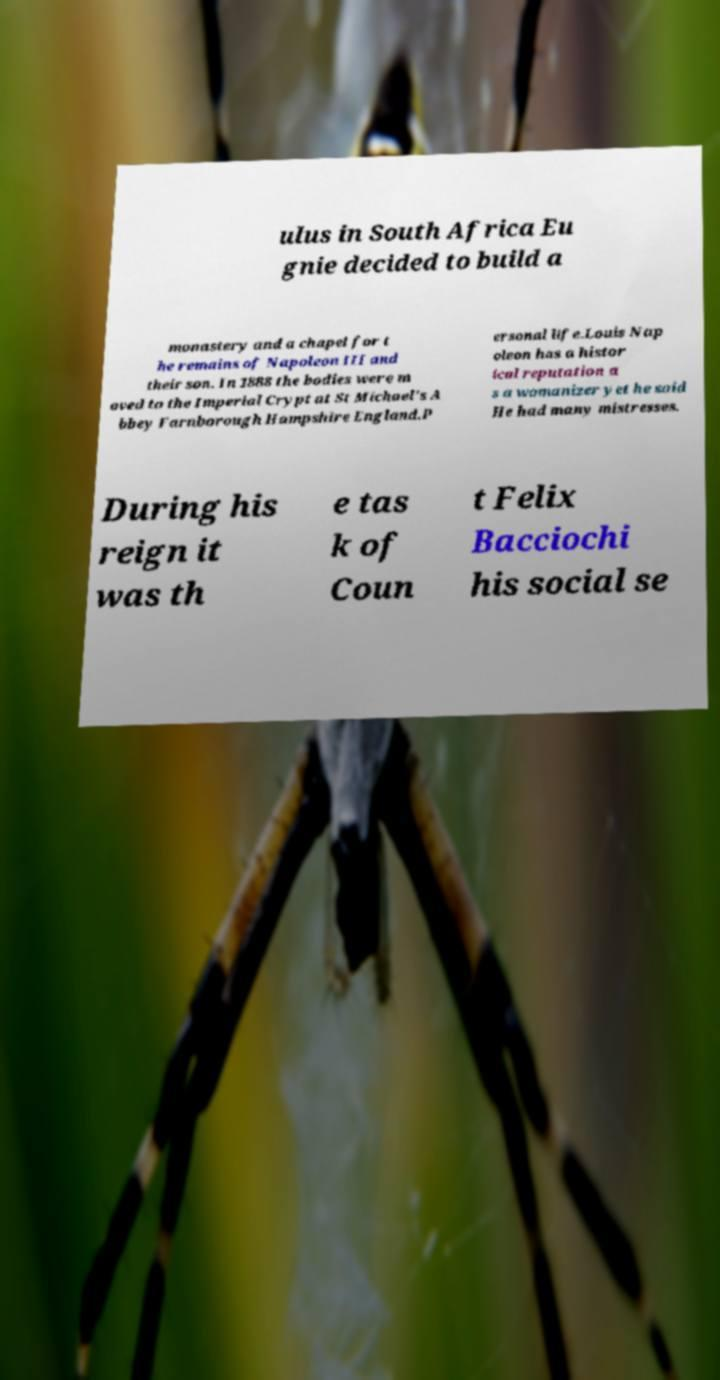Can you read and provide the text displayed in the image?This photo seems to have some interesting text. Can you extract and type it out for me? ulus in South Africa Eu gnie decided to build a monastery and a chapel for t he remains of Napoleon III and their son. In 1888 the bodies were m oved to the Imperial Crypt at St Michael's A bbey Farnborough Hampshire England.P ersonal life.Louis Nap oleon has a histor ical reputation a s a womanizer yet he said He had many mistresses. During his reign it was th e tas k of Coun t Felix Bacciochi his social se 